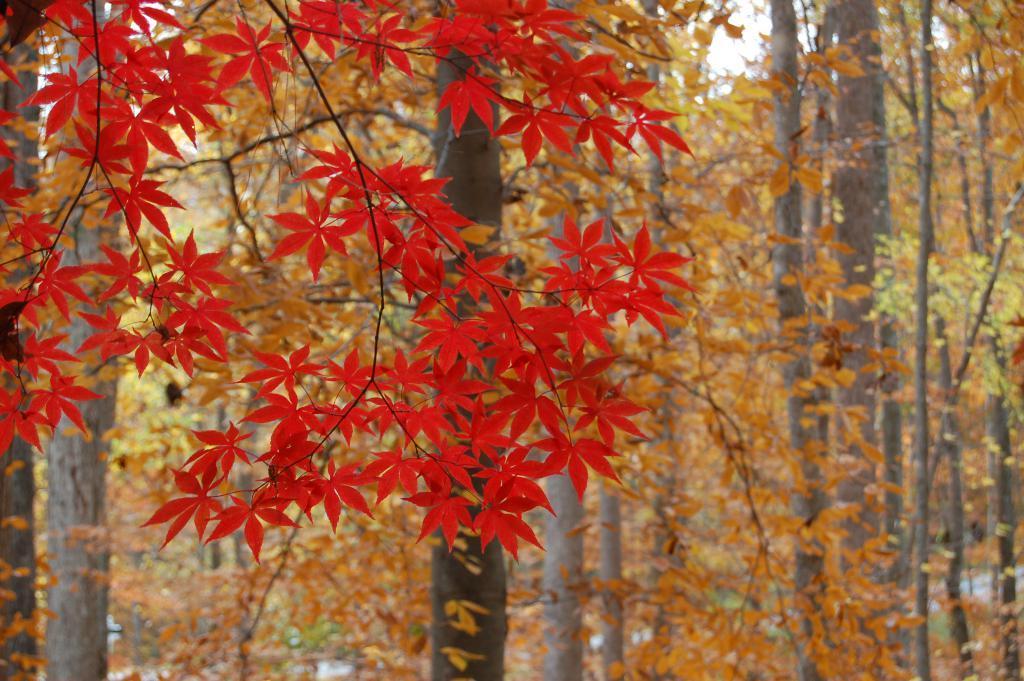Describe this image in one or two sentences. In this image we can see trees. In the background of the image there is the sky and other objects. 